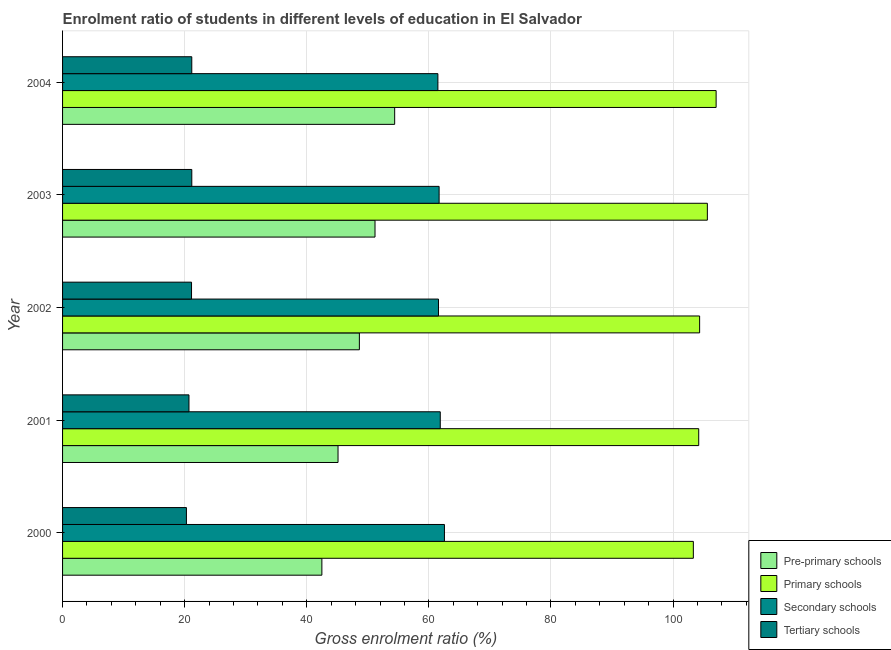Are the number of bars on each tick of the Y-axis equal?
Make the answer very short. Yes. What is the gross enrolment ratio in tertiary schools in 2000?
Offer a very short reply. 20.29. Across all years, what is the maximum gross enrolment ratio in secondary schools?
Make the answer very short. 62.56. Across all years, what is the minimum gross enrolment ratio in pre-primary schools?
Give a very brief answer. 42.48. In which year was the gross enrolment ratio in pre-primary schools minimum?
Provide a short and direct response. 2000. What is the total gross enrolment ratio in pre-primary schools in the graph?
Provide a succinct answer. 241.81. What is the difference between the gross enrolment ratio in secondary schools in 2002 and that in 2003?
Give a very brief answer. -0.1. What is the difference between the gross enrolment ratio in primary schools in 2003 and the gross enrolment ratio in tertiary schools in 2002?
Your response must be concise. 84.5. What is the average gross enrolment ratio in tertiary schools per year?
Your answer should be compact. 20.89. In the year 2002, what is the difference between the gross enrolment ratio in primary schools and gross enrolment ratio in secondary schools?
Your answer should be compact. 42.78. In how many years, is the gross enrolment ratio in primary schools greater than 60 %?
Ensure brevity in your answer.  5. What is the ratio of the gross enrolment ratio in pre-primary schools in 2000 to that in 2001?
Your response must be concise. 0.94. What is the difference between the highest and the second highest gross enrolment ratio in tertiary schools?
Offer a very short reply. 0. What is the difference between the highest and the lowest gross enrolment ratio in secondary schools?
Your answer should be compact. 1.07. Is the sum of the gross enrolment ratio in secondary schools in 2001 and 2004 greater than the maximum gross enrolment ratio in pre-primary schools across all years?
Offer a very short reply. Yes. Is it the case that in every year, the sum of the gross enrolment ratio in pre-primary schools and gross enrolment ratio in secondary schools is greater than the sum of gross enrolment ratio in tertiary schools and gross enrolment ratio in primary schools?
Your answer should be compact. Yes. What does the 1st bar from the top in 2000 represents?
Your answer should be compact. Tertiary schools. What does the 1st bar from the bottom in 2004 represents?
Your answer should be very brief. Pre-primary schools. Are all the bars in the graph horizontal?
Give a very brief answer. Yes. How many years are there in the graph?
Make the answer very short. 5. What is the difference between two consecutive major ticks on the X-axis?
Provide a succinct answer. 20. Where does the legend appear in the graph?
Your response must be concise. Bottom right. How many legend labels are there?
Ensure brevity in your answer.  4. What is the title of the graph?
Your answer should be very brief. Enrolment ratio of students in different levels of education in El Salvador. What is the label or title of the X-axis?
Your answer should be compact. Gross enrolment ratio (%). What is the label or title of the Y-axis?
Provide a short and direct response. Year. What is the Gross enrolment ratio (%) in Pre-primary schools in 2000?
Ensure brevity in your answer.  42.48. What is the Gross enrolment ratio (%) in Primary schools in 2000?
Offer a terse response. 103.33. What is the Gross enrolment ratio (%) of Secondary schools in 2000?
Make the answer very short. 62.56. What is the Gross enrolment ratio (%) of Tertiary schools in 2000?
Your answer should be compact. 20.29. What is the Gross enrolment ratio (%) of Pre-primary schools in 2001?
Give a very brief answer. 45.12. What is the Gross enrolment ratio (%) in Primary schools in 2001?
Your answer should be very brief. 104.21. What is the Gross enrolment ratio (%) in Secondary schools in 2001?
Make the answer very short. 61.87. What is the Gross enrolment ratio (%) in Tertiary schools in 2001?
Offer a very short reply. 20.71. What is the Gross enrolment ratio (%) in Pre-primary schools in 2002?
Your response must be concise. 48.62. What is the Gross enrolment ratio (%) of Primary schools in 2002?
Provide a short and direct response. 104.36. What is the Gross enrolment ratio (%) in Secondary schools in 2002?
Keep it short and to the point. 61.58. What is the Gross enrolment ratio (%) in Tertiary schools in 2002?
Your response must be concise. 21.13. What is the Gross enrolment ratio (%) in Pre-primary schools in 2003?
Offer a terse response. 51.18. What is the Gross enrolment ratio (%) of Primary schools in 2003?
Provide a short and direct response. 105.63. What is the Gross enrolment ratio (%) of Secondary schools in 2003?
Your answer should be compact. 61.68. What is the Gross enrolment ratio (%) in Tertiary schools in 2003?
Offer a terse response. 21.17. What is the Gross enrolment ratio (%) of Pre-primary schools in 2004?
Make the answer very short. 54.4. What is the Gross enrolment ratio (%) of Primary schools in 2004?
Provide a short and direct response. 107.06. What is the Gross enrolment ratio (%) in Secondary schools in 2004?
Offer a very short reply. 61.48. What is the Gross enrolment ratio (%) of Tertiary schools in 2004?
Offer a very short reply. 21.17. Across all years, what is the maximum Gross enrolment ratio (%) of Pre-primary schools?
Ensure brevity in your answer.  54.4. Across all years, what is the maximum Gross enrolment ratio (%) in Primary schools?
Your answer should be very brief. 107.06. Across all years, what is the maximum Gross enrolment ratio (%) of Secondary schools?
Your answer should be compact. 62.56. Across all years, what is the maximum Gross enrolment ratio (%) in Tertiary schools?
Your answer should be compact. 21.17. Across all years, what is the minimum Gross enrolment ratio (%) of Pre-primary schools?
Your answer should be compact. 42.48. Across all years, what is the minimum Gross enrolment ratio (%) in Primary schools?
Provide a succinct answer. 103.33. Across all years, what is the minimum Gross enrolment ratio (%) of Secondary schools?
Ensure brevity in your answer.  61.48. Across all years, what is the minimum Gross enrolment ratio (%) of Tertiary schools?
Provide a short and direct response. 20.29. What is the total Gross enrolment ratio (%) of Pre-primary schools in the graph?
Your response must be concise. 241.81. What is the total Gross enrolment ratio (%) in Primary schools in the graph?
Provide a short and direct response. 524.59. What is the total Gross enrolment ratio (%) of Secondary schools in the graph?
Offer a very short reply. 309.17. What is the total Gross enrolment ratio (%) of Tertiary schools in the graph?
Your answer should be compact. 104.46. What is the difference between the Gross enrolment ratio (%) of Pre-primary schools in 2000 and that in 2001?
Your answer should be very brief. -2.65. What is the difference between the Gross enrolment ratio (%) of Primary schools in 2000 and that in 2001?
Your response must be concise. -0.88. What is the difference between the Gross enrolment ratio (%) of Secondary schools in 2000 and that in 2001?
Give a very brief answer. 0.68. What is the difference between the Gross enrolment ratio (%) of Tertiary schools in 2000 and that in 2001?
Your answer should be very brief. -0.42. What is the difference between the Gross enrolment ratio (%) in Pre-primary schools in 2000 and that in 2002?
Your response must be concise. -6.14. What is the difference between the Gross enrolment ratio (%) in Primary schools in 2000 and that in 2002?
Your answer should be very brief. -1.03. What is the difference between the Gross enrolment ratio (%) in Secondary schools in 2000 and that in 2002?
Your answer should be compact. 0.98. What is the difference between the Gross enrolment ratio (%) of Tertiary schools in 2000 and that in 2002?
Offer a very short reply. -0.84. What is the difference between the Gross enrolment ratio (%) of Pre-primary schools in 2000 and that in 2003?
Your response must be concise. -8.71. What is the difference between the Gross enrolment ratio (%) in Primary schools in 2000 and that in 2003?
Your answer should be very brief. -2.3. What is the difference between the Gross enrolment ratio (%) of Secondary schools in 2000 and that in 2003?
Make the answer very short. 0.87. What is the difference between the Gross enrolment ratio (%) in Tertiary schools in 2000 and that in 2003?
Offer a very short reply. -0.88. What is the difference between the Gross enrolment ratio (%) of Pre-primary schools in 2000 and that in 2004?
Ensure brevity in your answer.  -11.93. What is the difference between the Gross enrolment ratio (%) in Primary schools in 2000 and that in 2004?
Keep it short and to the point. -3.73. What is the difference between the Gross enrolment ratio (%) in Secondary schools in 2000 and that in 2004?
Your response must be concise. 1.07. What is the difference between the Gross enrolment ratio (%) in Tertiary schools in 2000 and that in 2004?
Give a very brief answer. -0.88. What is the difference between the Gross enrolment ratio (%) in Pre-primary schools in 2001 and that in 2002?
Offer a very short reply. -3.5. What is the difference between the Gross enrolment ratio (%) in Primary schools in 2001 and that in 2002?
Offer a very short reply. -0.15. What is the difference between the Gross enrolment ratio (%) of Secondary schools in 2001 and that in 2002?
Offer a very short reply. 0.29. What is the difference between the Gross enrolment ratio (%) of Tertiary schools in 2001 and that in 2002?
Your answer should be compact. -0.42. What is the difference between the Gross enrolment ratio (%) of Pre-primary schools in 2001 and that in 2003?
Keep it short and to the point. -6.06. What is the difference between the Gross enrolment ratio (%) of Primary schools in 2001 and that in 2003?
Offer a very short reply. -1.42. What is the difference between the Gross enrolment ratio (%) of Secondary schools in 2001 and that in 2003?
Your answer should be compact. 0.19. What is the difference between the Gross enrolment ratio (%) of Tertiary schools in 2001 and that in 2003?
Ensure brevity in your answer.  -0.46. What is the difference between the Gross enrolment ratio (%) of Pre-primary schools in 2001 and that in 2004?
Offer a very short reply. -9.28. What is the difference between the Gross enrolment ratio (%) of Primary schools in 2001 and that in 2004?
Give a very brief answer. -2.85. What is the difference between the Gross enrolment ratio (%) in Secondary schools in 2001 and that in 2004?
Offer a terse response. 0.39. What is the difference between the Gross enrolment ratio (%) of Tertiary schools in 2001 and that in 2004?
Provide a short and direct response. -0.46. What is the difference between the Gross enrolment ratio (%) in Pre-primary schools in 2002 and that in 2003?
Offer a very short reply. -2.56. What is the difference between the Gross enrolment ratio (%) of Primary schools in 2002 and that in 2003?
Make the answer very short. -1.27. What is the difference between the Gross enrolment ratio (%) in Secondary schools in 2002 and that in 2003?
Keep it short and to the point. -0.1. What is the difference between the Gross enrolment ratio (%) in Tertiary schools in 2002 and that in 2003?
Your answer should be very brief. -0.04. What is the difference between the Gross enrolment ratio (%) of Pre-primary schools in 2002 and that in 2004?
Provide a short and direct response. -5.78. What is the difference between the Gross enrolment ratio (%) of Primary schools in 2002 and that in 2004?
Ensure brevity in your answer.  -2.7. What is the difference between the Gross enrolment ratio (%) in Secondary schools in 2002 and that in 2004?
Make the answer very short. 0.1. What is the difference between the Gross enrolment ratio (%) in Tertiary schools in 2002 and that in 2004?
Your response must be concise. -0.04. What is the difference between the Gross enrolment ratio (%) of Pre-primary schools in 2003 and that in 2004?
Make the answer very short. -3.22. What is the difference between the Gross enrolment ratio (%) of Primary schools in 2003 and that in 2004?
Make the answer very short. -1.43. What is the difference between the Gross enrolment ratio (%) in Secondary schools in 2003 and that in 2004?
Provide a succinct answer. 0.2. What is the difference between the Gross enrolment ratio (%) in Tertiary schools in 2003 and that in 2004?
Make the answer very short. 0. What is the difference between the Gross enrolment ratio (%) in Pre-primary schools in 2000 and the Gross enrolment ratio (%) in Primary schools in 2001?
Provide a succinct answer. -61.73. What is the difference between the Gross enrolment ratio (%) in Pre-primary schools in 2000 and the Gross enrolment ratio (%) in Secondary schools in 2001?
Provide a short and direct response. -19.39. What is the difference between the Gross enrolment ratio (%) of Pre-primary schools in 2000 and the Gross enrolment ratio (%) of Tertiary schools in 2001?
Your response must be concise. 21.77. What is the difference between the Gross enrolment ratio (%) of Primary schools in 2000 and the Gross enrolment ratio (%) of Secondary schools in 2001?
Offer a terse response. 41.46. What is the difference between the Gross enrolment ratio (%) in Primary schools in 2000 and the Gross enrolment ratio (%) in Tertiary schools in 2001?
Give a very brief answer. 82.62. What is the difference between the Gross enrolment ratio (%) in Secondary schools in 2000 and the Gross enrolment ratio (%) in Tertiary schools in 2001?
Your answer should be compact. 41.85. What is the difference between the Gross enrolment ratio (%) in Pre-primary schools in 2000 and the Gross enrolment ratio (%) in Primary schools in 2002?
Keep it short and to the point. -61.88. What is the difference between the Gross enrolment ratio (%) of Pre-primary schools in 2000 and the Gross enrolment ratio (%) of Secondary schools in 2002?
Offer a terse response. -19.1. What is the difference between the Gross enrolment ratio (%) in Pre-primary schools in 2000 and the Gross enrolment ratio (%) in Tertiary schools in 2002?
Provide a succinct answer. 21.35. What is the difference between the Gross enrolment ratio (%) of Primary schools in 2000 and the Gross enrolment ratio (%) of Secondary schools in 2002?
Offer a very short reply. 41.75. What is the difference between the Gross enrolment ratio (%) in Primary schools in 2000 and the Gross enrolment ratio (%) in Tertiary schools in 2002?
Your response must be concise. 82.2. What is the difference between the Gross enrolment ratio (%) of Secondary schools in 2000 and the Gross enrolment ratio (%) of Tertiary schools in 2002?
Offer a terse response. 41.43. What is the difference between the Gross enrolment ratio (%) in Pre-primary schools in 2000 and the Gross enrolment ratio (%) in Primary schools in 2003?
Provide a succinct answer. -63.15. What is the difference between the Gross enrolment ratio (%) in Pre-primary schools in 2000 and the Gross enrolment ratio (%) in Secondary schools in 2003?
Your answer should be compact. -19.2. What is the difference between the Gross enrolment ratio (%) in Pre-primary schools in 2000 and the Gross enrolment ratio (%) in Tertiary schools in 2003?
Offer a terse response. 21.31. What is the difference between the Gross enrolment ratio (%) in Primary schools in 2000 and the Gross enrolment ratio (%) in Secondary schools in 2003?
Ensure brevity in your answer.  41.65. What is the difference between the Gross enrolment ratio (%) in Primary schools in 2000 and the Gross enrolment ratio (%) in Tertiary schools in 2003?
Offer a very short reply. 82.16. What is the difference between the Gross enrolment ratio (%) in Secondary schools in 2000 and the Gross enrolment ratio (%) in Tertiary schools in 2003?
Give a very brief answer. 41.39. What is the difference between the Gross enrolment ratio (%) of Pre-primary schools in 2000 and the Gross enrolment ratio (%) of Primary schools in 2004?
Make the answer very short. -64.58. What is the difference between the Gross enrolment ratio (%) in Pre-primary schools in 2000 and the Gross enrolment ratio (%) in Secondary schools in 2004?
Your response must be concise. -19. What is the difference between the Gross enrolment ratio (%) of Pre-primary schools in 2000 and the Gross enrolment ratio (%) of Tertiary schools in 2004?
Keep it short and to the point. 21.31. What is the difference between the Gross enrolment ratio (%) of Primary schools in 2000 and the Gross enrolment ratio (%) of Secondary schools in 2004?
Make the answer very short. 41.85. What is the difference between the Gross enrolment ratio (%) in Primary schools in 2000 and the Gross enrolment ratio (%) in Tertiary schools in 2004?
Your response must be concise. 82.16. What is the difference between the Gross enrolment ratio (%) of Secondary schools in 2000 and the Gross enrolment ratio (%) of Tertiary schools in 2004?
Provide a succinct answer. 41.39. What is the difference between the Gross enrolment ratio (%) in Pre-primary schools in 2001 and the Gross enrolment ratio (%) in Primary schools in 2002?
Keep it short and to the point. -59.23. What is the difference between the Gross enrolment ratio (%) in Pre-primary schools in 2001 and the Gross enrolment ratio (%) in Secondary schools in 2002?
Provide a short and direct response. -16.46. What is the difference between the Gross enrolment ratio (%) of Pre-primary schools in 2001 and the Gross enrolment ratio (%) of Tertiary schools in 2002?
Keep it short and to the point. 24. What is the difference between the Gross enrolment ratio (%) in Primary schools in 2001 and the Gross enrolment ratio (%) in Secondary schools in 2002?
Provide a succinct answer. 42.63. What is the difference between the Gross enrolment ratio (%) of Primary schools in 2001 and the Gross enrolment ratio (%) of Tertiary schools in 2002?
Make the answer very short. 83.08. What is the difference between the Gross enrolment ratio (%) in Secondary schools in 2001 and the Gross enrolment ratio (%) in Tertiary schools in 2002?
Keep it short and to the point. 40.74. What is the difference between the Gross enrolment ratio (%) in Pre-primary schools in 2001 and the Gross enrolment ratio (%) in Primary schools in 2003?
Offer a terse response. -60.5. What is the difference between the Gross enrolment ratio (%) of Pre-primary schools in 2001 and the Gross enrolment ratio (%) of Secondary schools in 2003?
Your answer should be very brief. -16.56. What is the difference between the Gross enrolment ratio (%) of Pre-primary schools in 2001 and the Gross enrolment ratio (%) of Tertiary schools in 2003?
Your answer should be very brief. 23.95. What is the difference between the Gross enrolment ratio (%) of Primary schools in 2001 and the Gross enrolment ratio (%) of Secondary schools in 2003?
Keep it short and to the point. 42.53. What is the difference between the Gross enrolment ratio (%) in Primary schools in 2001 and the Gross enrolment ratio (%) in Tertiary schools in 2003?
Make the answer very short. 83.04. What is the difference between the Gross enrolment ratio (%) in Secondary schools in 2001 and the Gross enrolment ratio (%) in Tertiary schools in 2003?
Make the answer very short. 40.7. What is the difference between the Gross enrolment ratio (%) of Pre-primary schools in 2001 and the Gross enrolment ratio (%) of Primary schools in 2004?
Your answer should be very brief. -61.94. What is the difference between the Gross enrolment ratio (%) in Pre-primary schools in 2001 and the Gross enrolment ratio (%) in Secondary schools in 2004?
Your answer should be very brief. -16.36. What is the difference between the Gross enrolment ratio (%) in Pre-primary schools in 2001 and the Gross enrolment ratio (%) in Tertiary schools in 2004?
Make the answer very short. 23.96. What is the difference between the Gross enrolment ratio (%) of Primary schools in 2001 and the Gross enrolment ratio (%) of Secondary schools in 2004?
Make the answer very short. 42.73. What is the difference between the Gross enrolment ratio (%) in Primary schools in 2001 and the Gross enrolment ratio (%) in Tertiary schools in 2004?
Your response must be concise. 83.04. What is the difference between the Gross enrolment ratio (%) of Secondary schools in 2001 and the Gross enrolment ratio (%) of Tertiary schools in 2004?
Your answer should be compact. 40.7. What is the difference between the Gross enrolment ratio (%) in Pre-primary schools in 2002 and the Gross enrolment ratio (%) in Primary schools in 2003?
Offer a terse response. -57. What is the difference between the Gross enrolment ratio (%) in Pre-primary schools in 2002 and the Gross enrolment ratio (%) in Secondary schools in 2003?
Your answer should be very brief. -13.06. What is the difference between the Gross enrolment ratio (%) of Pre-primary schools in 2002 and the Gross enrolment ratio (%) of Tertiary schools in 2003?
Offer a terse response. 27.45. What is the difference between the Gross enrolment ratio (%) of Primary schools in 2002 and the Gross enrolment ratio (%) of Secondary schools in 2003?
Offer a terse response. 42.67. What is the difference between the Gross enrolment ratio (%) of Primary schools in 2002 and the Gross enrolment ratio (%) of Tertiary schools in 2003?
Offer a very short reply. 83.19. What is the difference between the Gross enrolment ratio (%) of Secondary schools in 2002 and the Gross enrolment ratio (%) of Tertiary schools in 2003?
Your response must be concise. 40.41. What is the difference between the Gross enrolment ratio (%) in Pre-primary schools in 2002 and the Gross enrolment ratio (%) in Primary schools in 2004?
Give a very brief answer. -58.44. What is the difference between the Gross enrolment ratio (%) of Pre-primary schools in 2002 and the Gross enrolment ratio (%) of Secondary schools in 2004?
Ensure brevity in your answer.  -12.86. What is the difference between the Gross enrolment ratio (%) in Pre-primary schools in 2002 and the Gross enrolment ratio (%) in Tertiary schools in 2004?
Offer a very short reply. 27.46. What is the difference between the Gross enrolment ratio (%) in Primary schools in 2002 and the Gross enrolment ratio (%) in Secondary schools in 2004?
Offer a terse response. 42.88. What is the difference between the Gross enrolment ratio (%) of Primary schools in 2002 and the Gross enrolment ratio (%) of Tertiary schools in 2004?
Keep it short and to the point. 83.19. What is the difference between the Gross enrolment ratio (%) in Secondary schools in 2002 and the Gross enrolment ratio (%) in Tertiary schools in 2004?
Your answer should be compact. 40.41. What is the difference between the Gross enrolment ratio (%) of Pre-primary schools in 2003 and the Gross enrolment ratio (%) of Primary schools in 2004?
Your answer should be compact. -55.88. What is the difference between the Gross enrolment ratio (%) of Pre-primary schools in 2003 and the Gross enrolment ratio (%) of Secondary schools in 2004?
Make the answer very short. -10.3. What is the difference between the Gross enrolment ratio (%) of Pre-primary schools in 2003 and the Gross enrolment ratio (%) of Tertiary schools in 2004?
Make the answer very short. 30.02. What is the difference between the Gross enrolment ratio (%) of Primary schools in 2003 and the Gross enrolment ratio (%) of Secondary schools in 2004?
Keep it short and to the point. 44.14. What is the difference between the Gross enrolment ratio (%) of Primary schools in 2003 and the Gross enrolment ratio (%) of Tertiary schools in 2004?
Your answer should be very brief. 84.46. What is the difference between the Gross enrolment ratio (%) of Secondary schools in 2003 and the Gross enrolment ratio (%) of Tertiary schools in 2004?
Provide a short and direct response. 40.52. What is the average Gross enrolment ratio (%) in Pre-primary schools per year?
Make the answer very short. 48.36. What is the average Gross enrolment ratio (%) in Primary schools per year?
Provide a short and direct response. 104.92. What is the average Gross enrolment ratio (%) of Secondary schools per year?
Keep it short and to the point. 61.83. What is the average Gross enrolment ratio (%) of Tertiary schools per year?
Provide a succinct answer. 20.89. In the year 2000, what is the difference between the Gross enrolment ratio (%) in Pre-primary schools and Gross enrolment ratio (%) in Primary schools?
Provide a short and direct response. -60.85. In the year 2000, what is the difference between the Gross enrolment ratio (%) of Pre-primary schools and Gross enrolment ratio (%) of Secondary schools?
Provide a short and direct response. -20.08. In the year 2000, what is the difference between the Gross enrolment ratio (%) of Pre-primary schools and Gross enrolment ratio (%) of Tertiary schools?
Keep it short and to the point. 22.19. In the year 2000, what is the difference between the Gross enrolment ratio (%) in Primary schools and Gross enrolment ratio (%) in Secondary schools?
Provide a succinct answer. 40.78. In the year 2000, what is the difference between the Gross enrolment ratio (%) of Primary schools and Gross enrolment ratio (%) of Tertiary schools?
Offer a very short reply. 83.04. In the year 2000, what is the difference between the Gross enrolment ratio (%) of Secondary schools and Gross enrolment ratio (%) of Tertiary schools?
Your answer should be compact. 42.26. In the year 2001, what is the difference between the Gross enrolment ratio (%) of Pre-primary schools and Gross enrolment ratio (%) of Primary schools?
Give a very brief answer. -59.09. In the year 2001, what is the difference between the Gross enrolment ratio (%) of Pre-primary schools and Gross enrolment ratio (%) of Secondary schools?
Make the answer very short. -16.75. In the year 2001, what is the difference between the Gross enrolment ratio (%) of Pre-primary schools and Gross enrolment ratio (%) of Tertiary schools?
Offer a terse response. 24.42. In the year 2001, what is the difference between the Gross enrolment ratio (%) in Primary schools and Gross enrolment ratio (%) in Secondary schools?
Give a very brief answer. 42.34. In the year 2001, what is the difference between the Gross enrolment ratio (%) in Primary schools and Gross enrolment ratio (%) in Tertiary schools?
Keep it short and to the point. 83.5. In the year 2001, what is the difference between the Gross enrolment ratio (%) of Secondary schools and Gross enrolment ratio (%) of Tertiary schools?
Make the answer very short. 41.17. In the year 2002, what is the difference between the Gross enrolment ratio (%) of Pre-primary schools and Gross enrolment ratio (%) of Primary schools?
Make the answer very short. -55.74. In the year 2002, what is the difference between the Gross enrolment ratio (%) in Pre-primary schools and Gross enrolment ratio (%) in Secondary schools?
Keep it short and to the point. -12.96. In the year 2002, what is the difference between the Gross enrolment ratio (%) in Pre-primary schools and Gross enrolment ratio (%) in Tertiary schools?
Keep it short and to the point. 27.5. In the year 2002, what is the difference between the Gross enrolment ratio (%) of Primary schools and Gross enrolment ratio (%) of Secondary schools?
Your answer should be compact. 42.78. In the year 2002, what is the difference between the Gross enrolment ratio (%) of Primary schools and Gross enrolment ratio (%) of Tertiary schools?
Keep it short and to the point. 83.23. In the year 2002, what is the difference between the Gross enrolment ratio (%) of Secondary schools and Gross enrolment ratio (%) of Tertiary schools?
Your response must be concise. 40.45. In the year 2003, what is the difference between the Gross enrolment ratio (%) in Pre-primary schools and Gross enrolment ratio (%) in Primary schools?
Make the answer very short. -54.44. In the year 2003, what is the difference between the Gross enrolment ratio (%) in Pre-primary schools and Gross enrolment ratio (%) in Secondary schools?
Keep it short and to the point. -10.5. In the year 2003, what is the difference between the Gross enrolment ratio (%) of Pre-primary schools and Gross enrolment ratio (%) of Tertiary schools?
Keep it short and to the point. 30.01. In the year 2003, what is the difference between the Gross enrolment ratio (%) of Primary schools and Gross enrolment ratio (%) of Secondary schools?
Offer a very short reply. 43.94. In the year 2003, what is the difference between the Gross enrolment ratio (%) of Primary schools and Gross enrolment ratio (%) of Tertiary schools?
Keep it short and to the point. 84.46. In the year 2003, what is the difference between the Gross enrolment ratio (%) in Secondary schools and Gross enrolment ratio (%) in Tertiary schools?
Ensure brevity in your answer.  40.51. In the year 2004, what is the difference between the Gross enrolment ratio (%) of Pre-primary schools and Gross enrolment ratio (%) of Primary schools?
Provide a short and direct response. -52.66. In the year 2004, what is the difference between the Gross enrolment ratio (%) of Pre-primary schools and Gross enrolment ratio (%) of Secondary schools?
Provide a short and direct response. -7.08. In the year 2004, what is the difference between the Gross enrolment ratio (%) of Pre-primary schools and Gross enrolment ratio (%) of Tertiary schools?
Keep it short and to the point. 33.24. In the year 2004, what is the difference between the Gross enrolment ratio (%) of Primary schools and Gross enrolment ratio (%) of Secondary schools?
Your answer should be very brief. 45.58. In the year 2004, what is the difference between the Gross enrolment ratio (%) in Primary schools and Gross enrolment ratio (%) in Tertiary schools?
Your response must be concise. 85.9. In the year 2004, what is the difference between the Gross enrolment ratio (%) in Secondary schools and Gross enrolment ratio (%) in Tertiary schools?
Ensure brevity in your answer.  40.32. What is the ratio of the Gross enrolment ratio (%) of Pre-primary schools in 2000 to that in 2001?
Offer a very short reply. 0.94. What is the ratio of the Gross enrolment ratio (%) of Primary schools in 2000 to that in 2001?
Offer a terse response. 0.99. What is the ratio of the Gross enrolment ratio (%) in Secondary schools in 2000 to that in 2001?
Provide a succinct answer. 1.01. What is the ratio of the Gross enrolment ratio (%) of Tertiary schools in 2000 to that in 2001?
Your answer should be compact. 0.98. What is the ratio of the Gross enrolment ratio (%) in Pre-primary schools in 2000 to that in 2002?
Keep it short and to the point. 0.87. What is the ratio of the Gross enrolment ratio (%) in Primary schools in 2000 to that in 2002?
Make the answer very short. 0.99. What is the ratio of the Gross enrolment ratio (%) of Secondary schools in 2000 to that in 2002?
Ensure brevity in your answer.  1.02. What is the ratio of the Gross enrolment ratio (%) of Tertiary schools in 2000 to that in 2002?
Your answer should be very brief. 0.96. What is the ratio of the Gross enrolment ratio (%) in Pre-primary schools in 2000 to that in 2003?
Provide a succinct answer. 0.83. What is the ratio of the Gross enrolment ratio (%) of Primary schools in 2000 to that in 2003?
Your response must be concise. 0.98. What is the ratio of the Gross enrolment ratio (%) in Secondary schools in 2000 to that in 2003?
Offer a very short reply. 1.01. What is the ratio of the Gross enrolment ratio (%) of Tertiary schools in 2000 to that in 2003?
Provide a short and direct response. 0.96. What is the ratio of the Gross enrolment ratio (%) of Pre-primary schools in 2000 to that in 2004?
Your answer should be compact. 0.78. What is the ratio of the Gross enrolment ratio (%) of Primary schools in 2000 to that in 2004?
Ensure brevity in your answer.  0.97. What is the ratio of the Gross enrolment ratio (%) in Secondary schools in 2000 to that in 2004?
Make the answer very short. 1.02. What is the ratio of the Gross enrolment ratio (%) in Tertiary schools in 2000 to that in 2004?
Your answer should be very brief. 0.96. What is the ratio of the Gross enrolment ratio (%) of Pre-primary schools in 2001 to that in 2002?
Your answer should be compact. 0.93. What is the ratio of the Gross enrolment ratio (%) in Primary schools in 2001 to that in 2002?
Keep it short and to the point. 1. What is the ratio of the Gross enrolment ratio (%) of Secondary schools in 2001 to that in 2002?
Offer a very short reply. 1. What is the ratio of the Gross enrolment ratio (%) in Tertiary schools in 2001 to that in 2002?
Your response must be concise. 0.98. What is the ratio of the Gross enrolment ratio (%) of Pre-primary schools in 2001 to that in 2003?
Provide a succinct answer. 0.88. What is the ratio of the Gross enrolment ratio (%) in Primary schools in 2001 to that in 2003?
Provide a short and direct response. 0.99. What is the ratio of the Gross enrolment ratio (%) in Secondary schools in 2001 to that in 2003?
Keep it short and to the point. 1. What is the ratio of the Gross enrolment ratio (%) in Tertiary schools in 2001 to that in 2003?
Make the answer very short. 0.98. What is the ratio of the Gross enrolment ratio (%) of Pre-primary schools in 2001 to that in 2004?
Your answer should be compact. 0.83. What is the ratio of the Gross enrolment ratio (%) of Primary schools in 2001 to that in 2004?
Your answer should be very brief. 0.97. What is the ratio of the Gross enrolment ratio (%) of Secondary schools in 2001 to that in 2004?
Your answer should be very brief. 1.01. What is the ratio of the Gross enrolment ratio (%) in Tertiary schools in 2001 to that in 2004?
Your answer should be very brief. 0.98. What is the ratio of the Gross enrolment ratio (%) of Pre-primary schools in 2002 to that in 2003?
Offer a terse response. 0.95. What is the ratio of the Gross enrolment ratio (%) of Secondary schools in 2002 to that in 2003?
Keep it short and to the point. 1. What is the ratio of the Gross enrolment ratio (%) of Pre-primary schools in 2002 to that in 2004?
Keep it short and to the point. 0.89. What is the ratio of the Gross enrolment ratio (%) in Primary schools in 2002 to that in 2004?
Make the answer very short. 0.97. What is the ratio of the Gross enrolment ratio (%) in Secondary schools in 2002 to that in 2004?
Provide a short and direct response. 1. What is the ratio of the Gross enrolment ratio (%) in Tertiary schools in 2002 to that in 2004?
Offer a very short reply. 1. What is the ratio of the Gross enrolment ratio (%) of Pre-primary schools in 2003 to that in 2004?
Your answer should be very brief. 0.94. What is the ratio of the Gross enrolment ratio (%) in Primary schools in 2003 to that in 2004?
Your answer should be compact. 0.99. What is the difference between the highest and the second highest Gross enrolment ratio (%) of Pre-primary schools?
Provide a succinct answer. 3.22. What is the difference between the highest and the second highest Gross enrolment ratio (%) in Primary schools?
Offer a terse response. 1.43. What is the difference between the highest and the second highest Gross enrolment ratio (%) of Secondary schools?
Ensure brevity in your answer.  0.68. What is the difference between the highest and the second highest Gross enrolment ratio (%) of Tertiary schools?
Give a very brief answer. 0. What is the difference between the highest and the lowest Gross enrolment ratio (%) of Pre-primary schools?
Your response must be concise. 11.93. What is the difference between the highest and the lowest Gross enrolment ratio (%) in Primary schools?
Offer a very short reply. 3.73. What is the difference between the highest and the lowest Gross enrolment ratio (%) in Secondary schools?
Offer a very short reply. 1.07. What is the difference between the highest and the lowest Gross enrolment ratio (%) in Tertiary schools?
Provide a short and direct response. 0.88. 